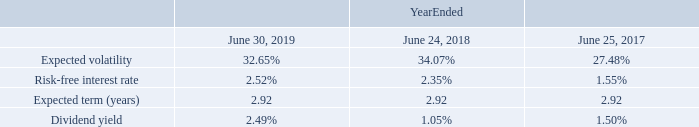The fair value of the Company’s service-based RSUs was calculated based on fair market value of the Company’s stock at the date of grant, discounted for dividends.
The fair value of the Company’s market-based PRSUs granted during fiscal years 2019, 2018, and 2017 was calculated using a Monte Carlo simulation model at the date of the grant. This model requires the input of highly subjective assumptions, including expected stock price volatility and the estimated life of each award:
As of June 30, 2019, the Company had $271.9 million of total unrecognized compensation expense related to all unvested RSUs granted which is expected to be recognized over a weighted-average remaining period of 2.2 years.
How was the fair value of the Company’s service-based RSUs calculated? Based on fair market value of the company’s stock at the date of grant, discounted for dividends. Which model was used for the calculation of the fair value of the Company’s market-based PRSUs granted during fiscal years 2019, 2018, and 2017? Monte carlo simulation model. What is the amount of total unrecognised compensation expense as of June 30, 2019? $271.9 million. What is the change in the expected volatility from 2018 to 2019?
Answer scale should be: percent. 32.65-34.07
Answer: -1.42. What is the change in the risk-free interest rate from 2018 to 2019?
Answer scale should be: percent. 2.52-2.35
Answer: 0.17. What is the change in the dividend yield from 2018 to 2019?
Answer scale should be: percent. 2.49-1.05
Answer: 1.44. 